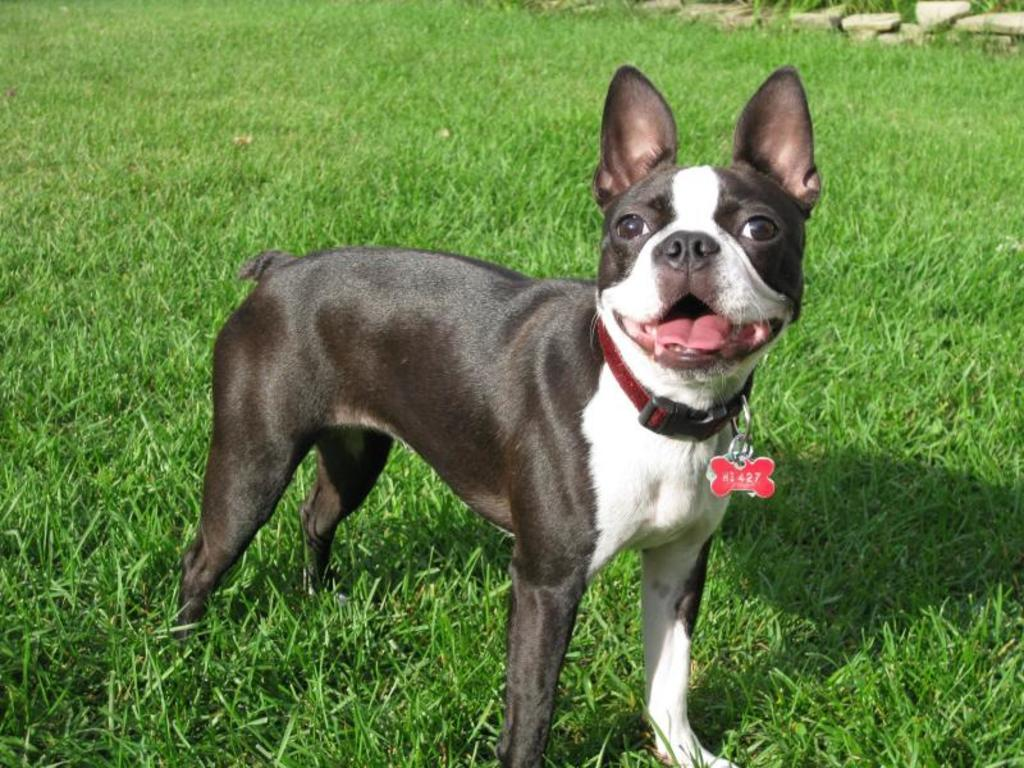What animal can be seen in the image? There is a dog in the image. Where is the dog located? The dog is standing on the grass. What type of bone is the pig holding in the image? There is no pig or bone present in the image; it features a dog standing on the grass. What time of day is depicted in the image? The provided facts do not mention the time of day, so it cannot be determined from the image. 